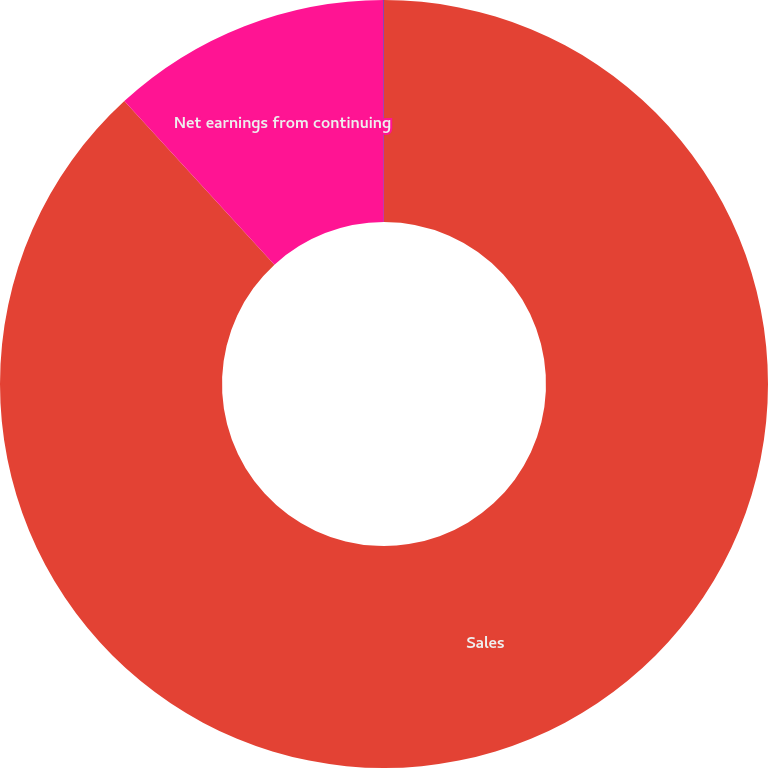Convert chart to OTSL. <chart><loc_0><loc_0><loc_500><loc_500><pie_chart><fcel>Sales<fcel>Net earnings from continuing<fcel>Diluted net earnings per share<nl><fcel>88.18%<fcel>11.8%<fcel>0.02%<nl></chart> 